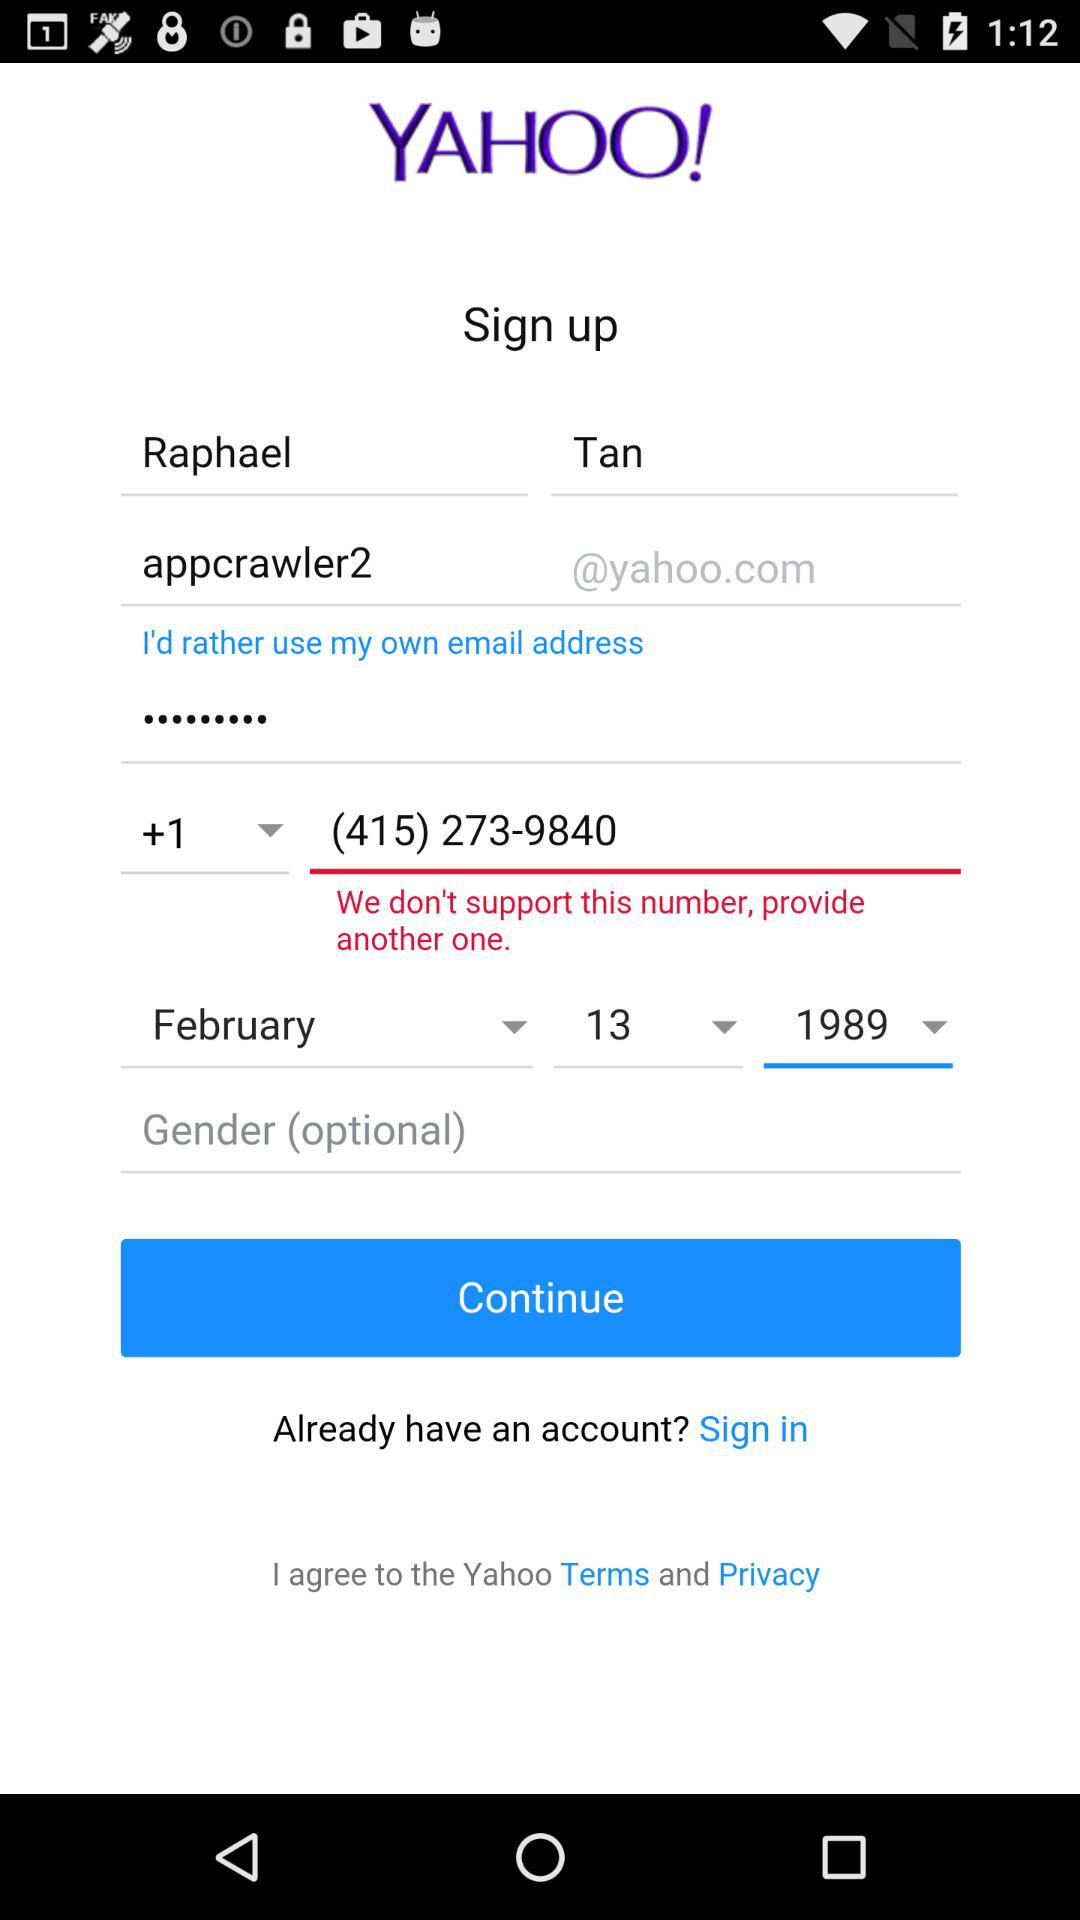What is the date of birth? The date of birth is February 13, 1989. 